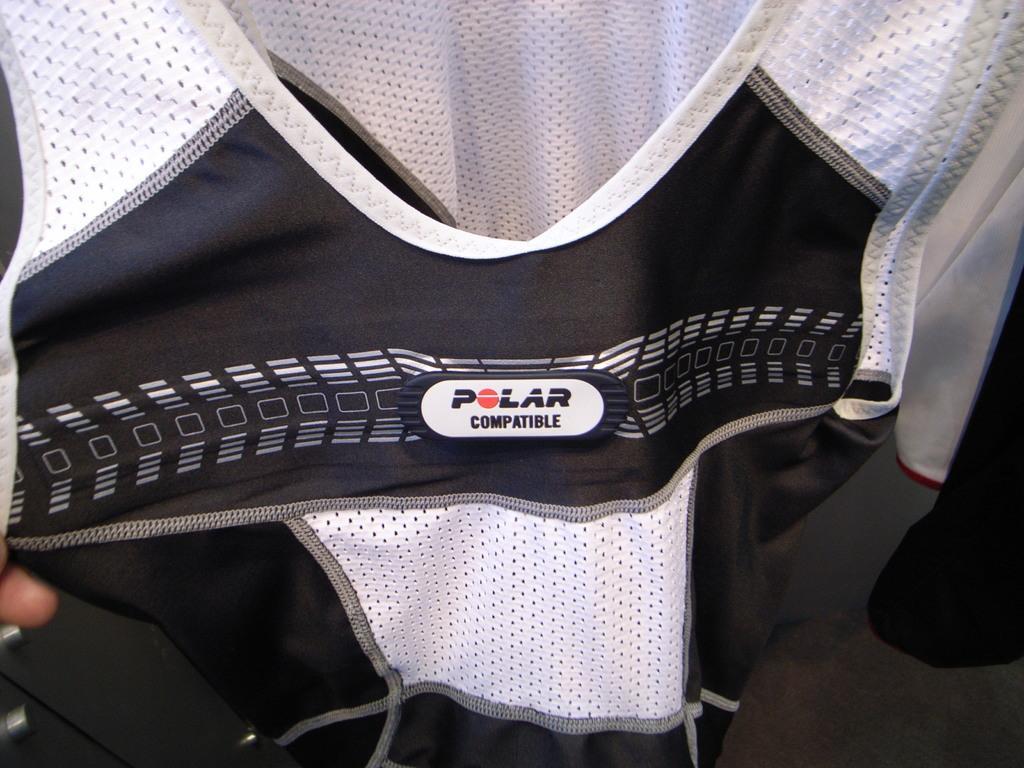How would you summarize this image in a sentence or two? In the image we can see a black and white color jacket and the floor. 